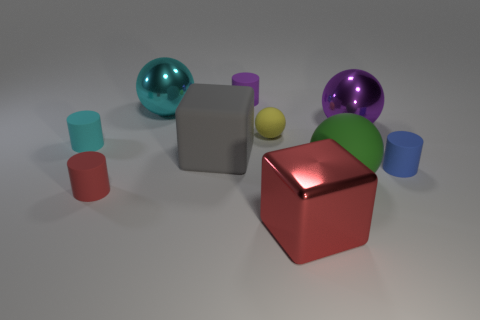Subtract 1 spheres. How many spheres are left? 3 Subtract all cylinders. How many objects are left? 6 Add 4 tiny gray metal balls. How many tiny gray metal balls exist? 4 Subtract 1 gray blocks. How many objects are left? 9 Subtract all green balls. Subtract all red matte cylinders. How many objects are left? 8 Add 7 big green spheres. How many big green spheres are left? 8 